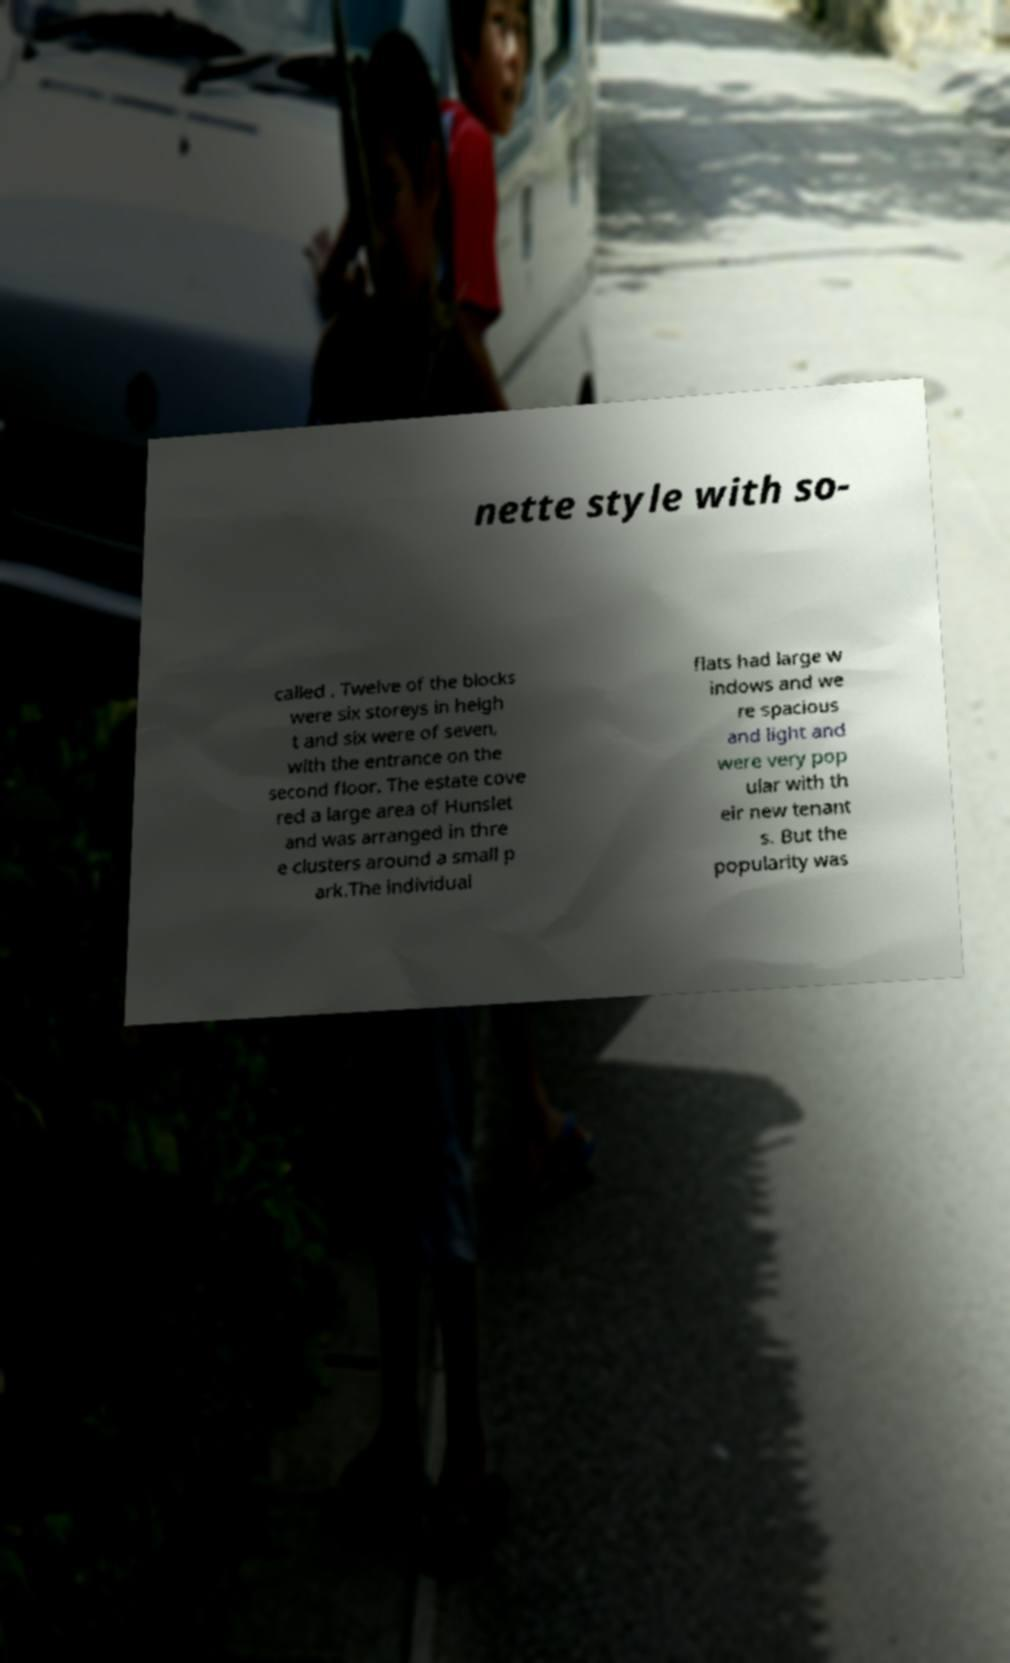Could you extract and type out the text from this image? nette style with so- called . Twelve of the blocks were six storeys in heigh t and six were of seven, with the entrance on the second floor. The estate cove red a large area of Hunslet and was arranged in thre e clusters around a small p ark.The individual flats had large w indows and we re spacious and light and were very pop ular with th eir new tenant s. But the popularity was 